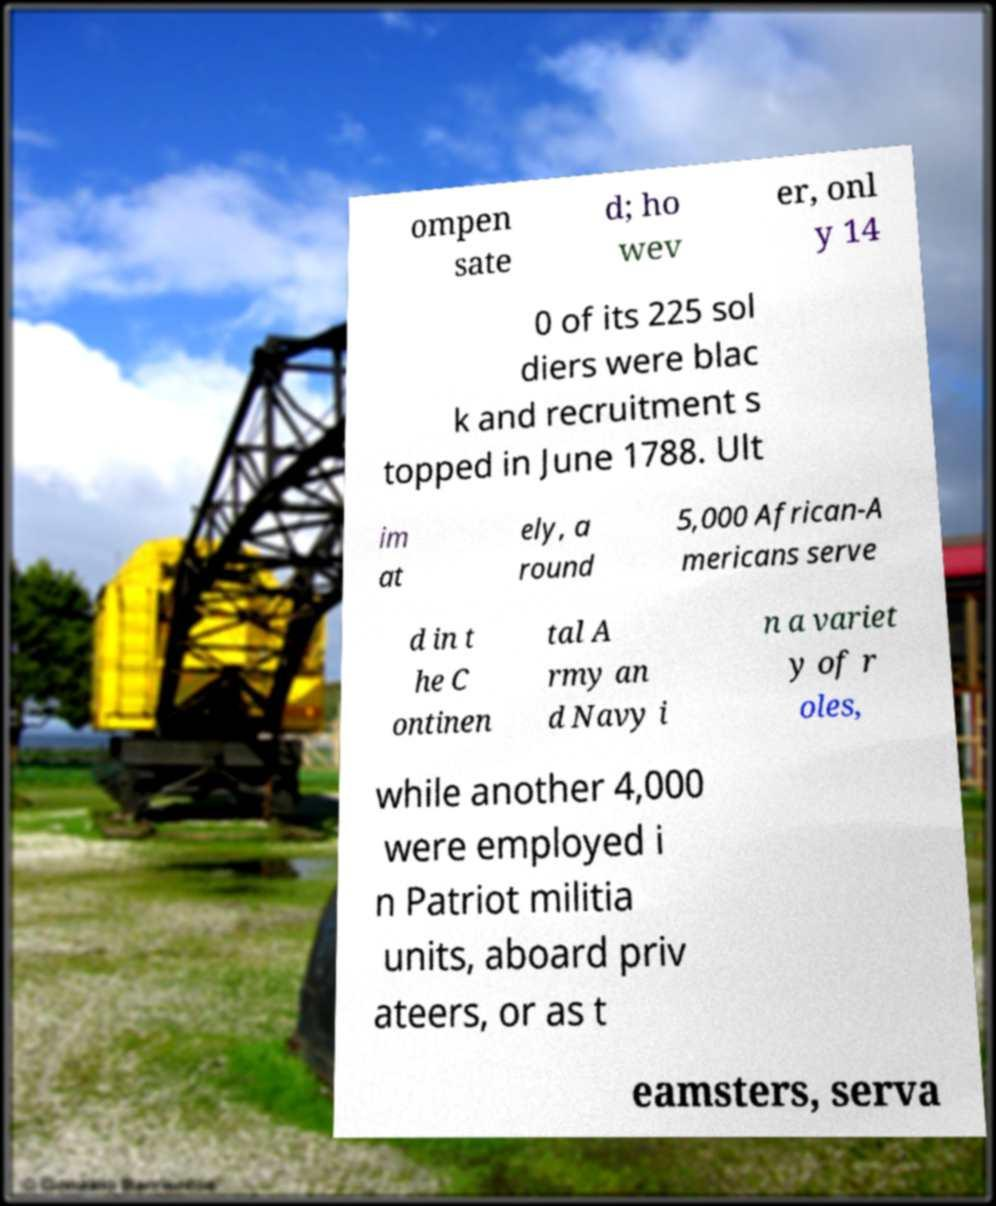Please read and relay the text visible in this image. What does it say? ompen sate d; ho wev er, onl y 14 0 of its 225 sol diers were blac k and recruitment s topped in June 1788. Ult im at ely, a round 5,000 African-A mericans serve d in t he C ontinen tal A rmy an d Navy i n a variet y of r oles, while another 4,000 were employed i n Patriot militia units, aboard priv ateers, or as t eamsters, serva 